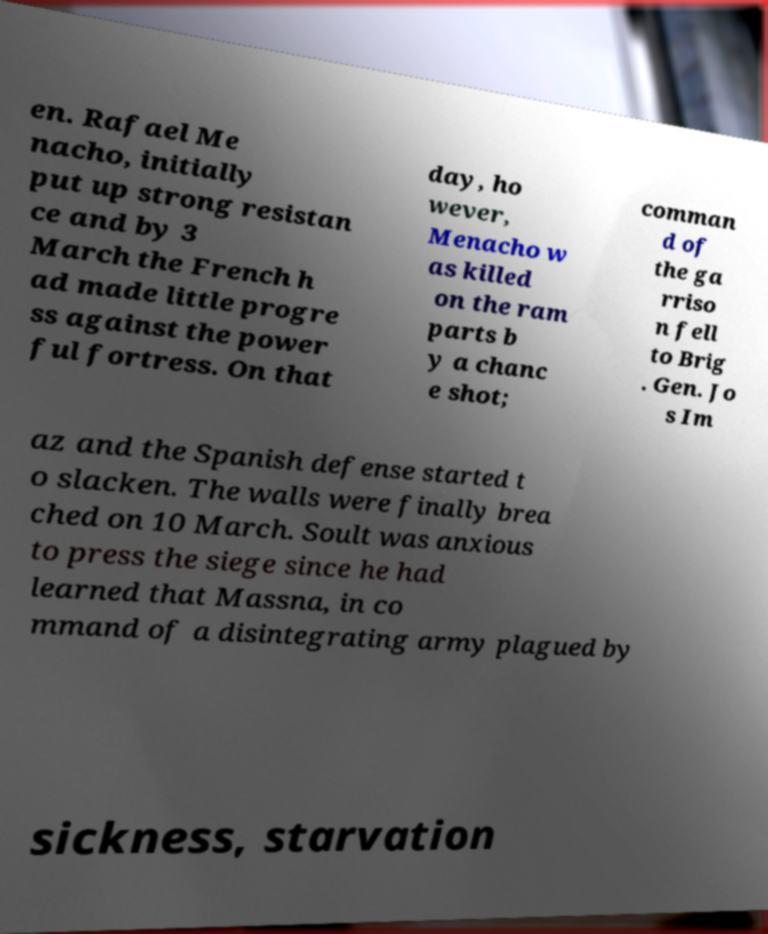There's text embedded in this image that I need extracted. Can you transcribe it verbatim? en. Rafael Me nacho, initially put up strong resistan ce and by 3 March the French h ad made little progre ss against the power ful fortress. On that day, ho wever, Menacho w as killed on the ram parts b y a chanc e shot; comman d of the ga rriso n fell to Brig . Gen. Jo s Im az and the Spanish defense started t o slacken. The walls were finally brea ched on 10 March. Soult was anxious to press the siege since he had learned that Massna, in co mmand of a disintegrating army plagued by sickness, starvation 